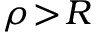<formula> <loc_0><loc_0><loc_500><loc_500>\rho \, > \, R</formula> 